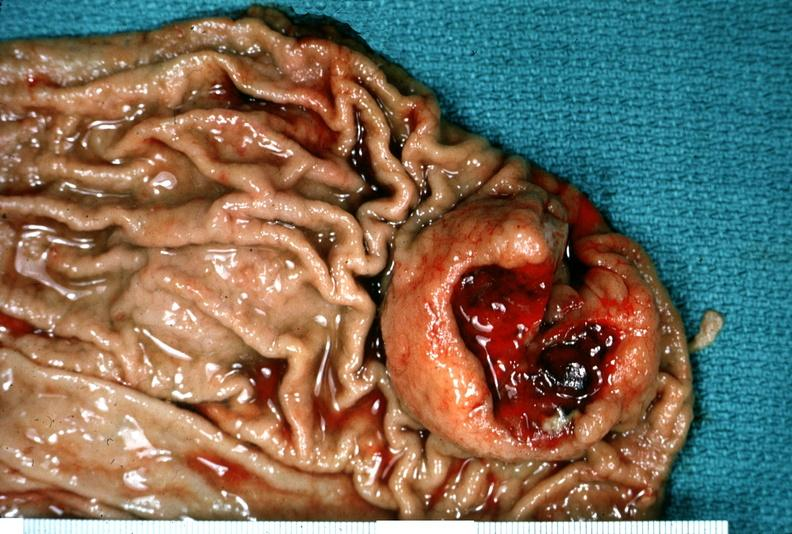what does this image show?
Answer the question using a single word or phrase. Stomach 